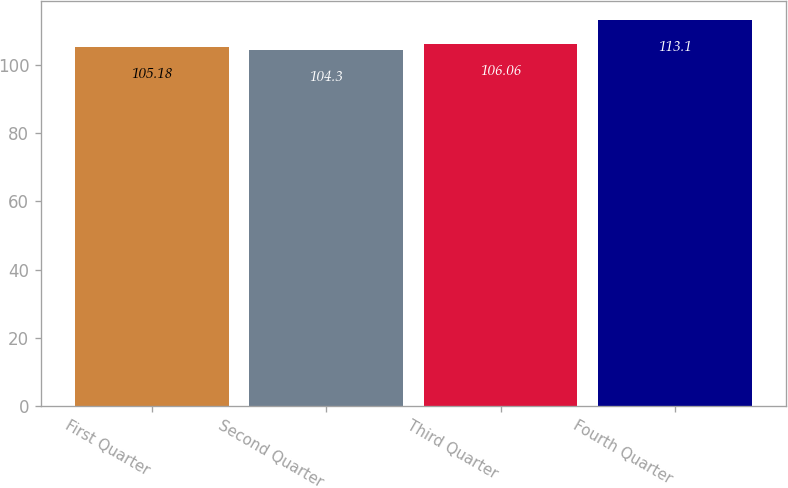<chart> <loc_0><loc_0><loc_500><loc_500><bar_chart><fcel>First Quarter<fcel>Second Quarter<fcel>Third Quarter<fcel>Fourth Quarter<nl><fcel>105.18<fcel>104.3<fcel>106.06<fcel>113.1<nl></chart> 